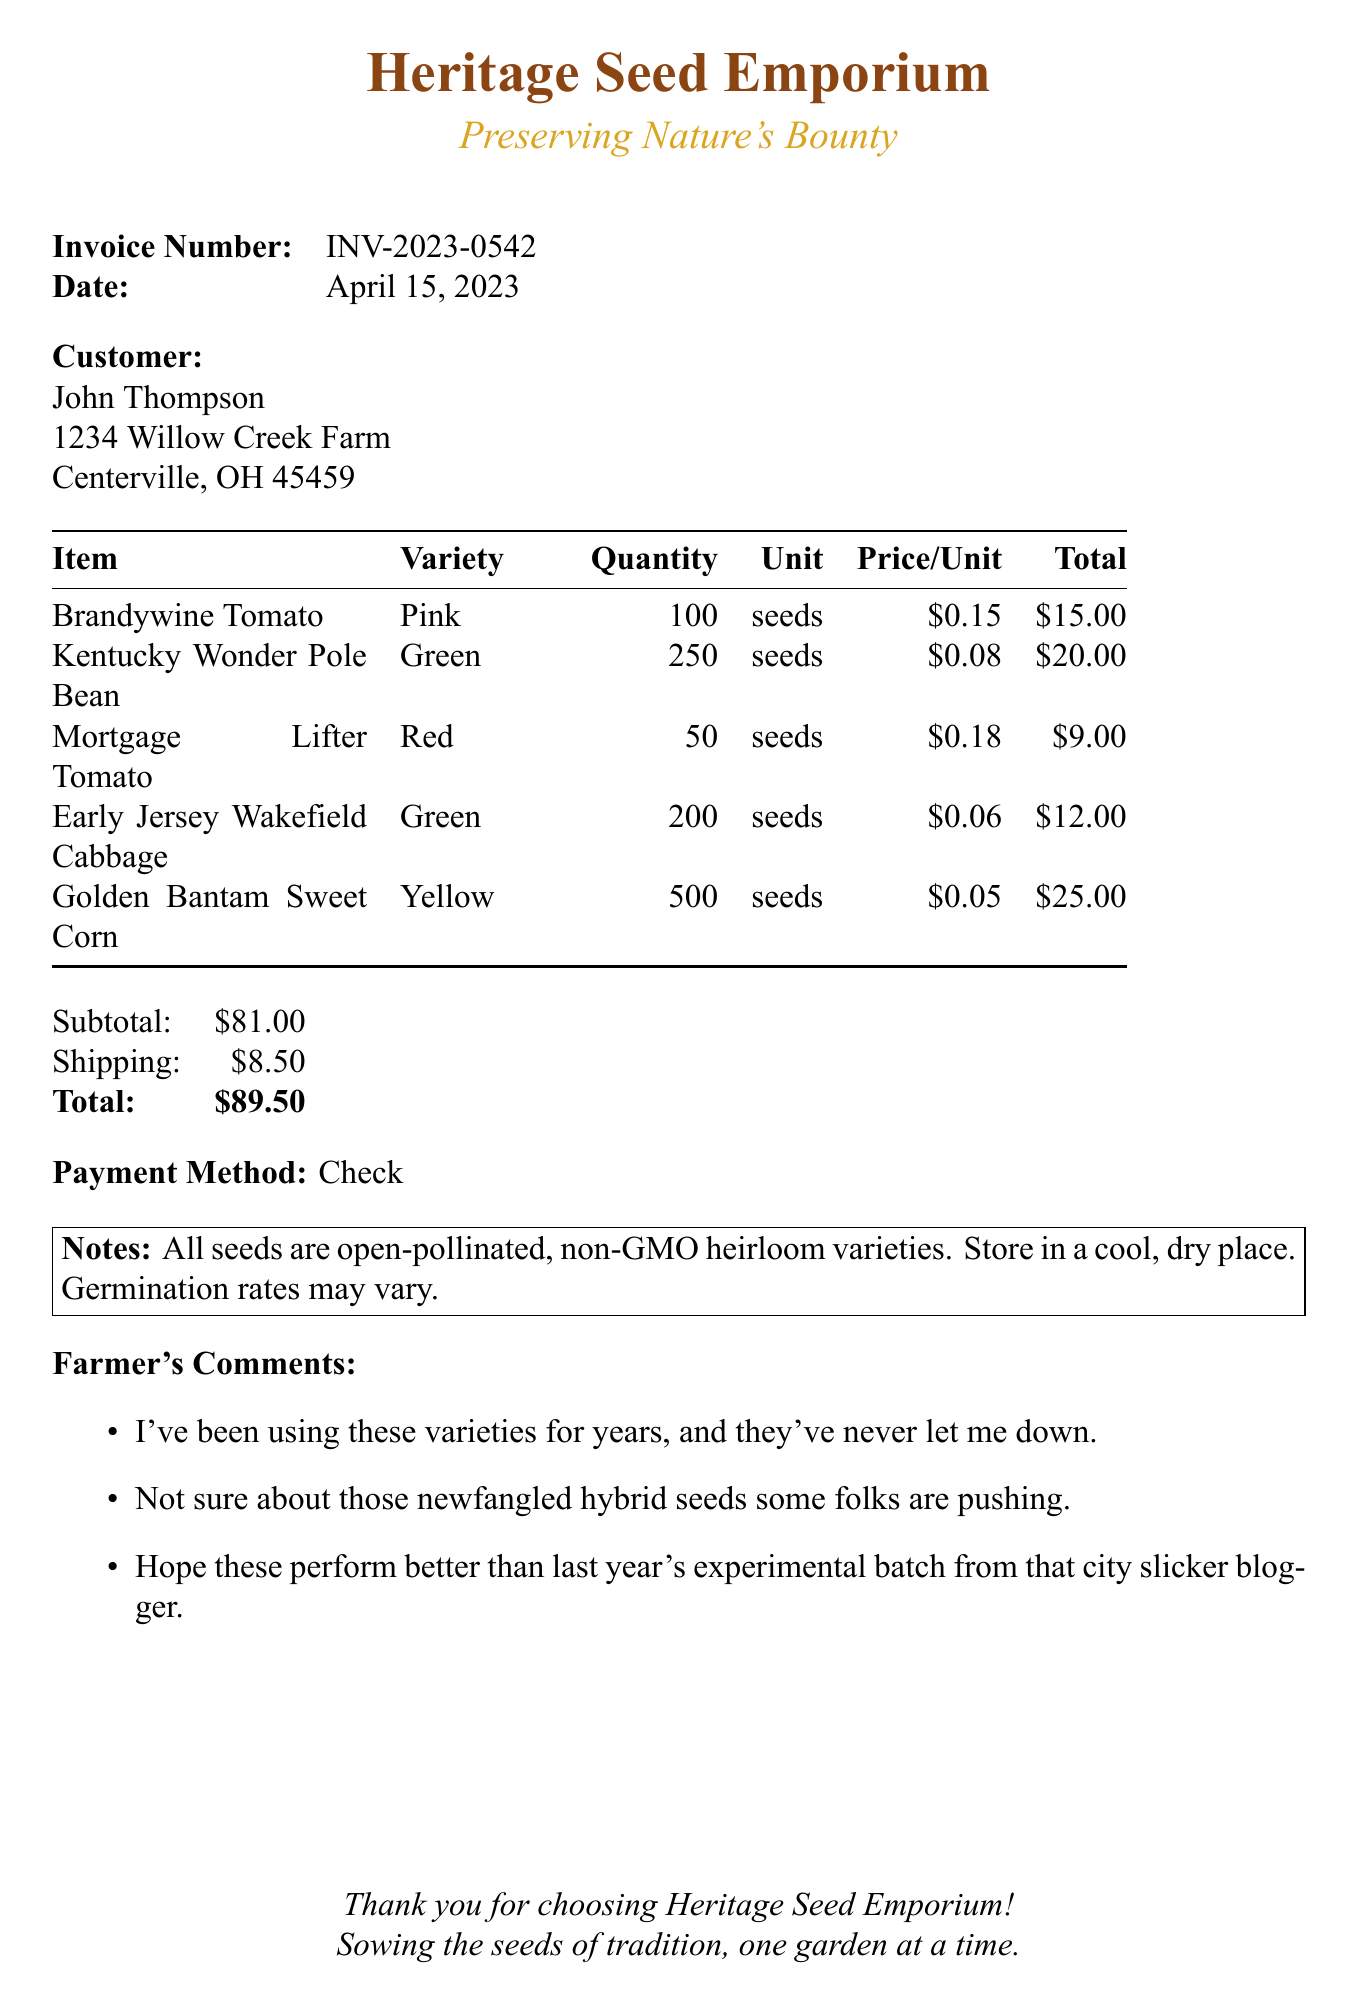What is the company name? The company name is listed at the top of the document as the supplier of the seeds.
Answer: Heritage Seed Emporium What is the invoice number? The invoice number is specified in the document for tracking purposes.
Answer: INV-2023-0542 What is the date of the invoice? The date indicates when the transaction took place as recorded in the document.
Answer: April 15, 2023 What is the total amount due? The total amount is the sum of the subtotal and shipping, clearly stated in the document.
Answer: $89.50 How many Golden Bantam Sweet Corn seeds were purchased? This quantity indicates the number of seeds for this specific variety in the order.
Answer: 500 Which payment method was used? The payment method specifies how the customer settled the invoice, as noted in the document.
Answer: Check What is the subtotal of the items purchased? The subtotal reflects the total cost of items before shipping is added.
Answer: $81.00 Are the seeds GMO? This indicates the nature of the seeds being sold, a specific detail mentioned in the document’s notes.
Answer: Non-GMO What is one of the farmer's comments about the seeds? This question assesses understanding of the farmer's sentiment regarding past experiences with the seeds.
Answer: I've been using these varieties for years, and they've never let me down 